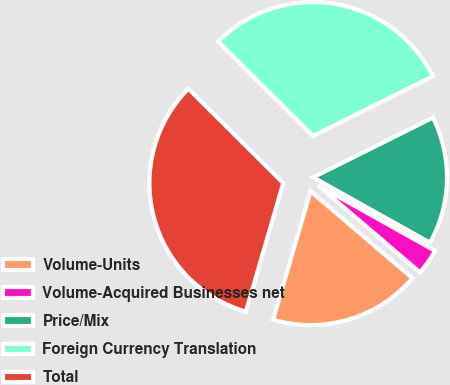<chart> <loc_0><loc_0><loc_500><loc_500><pie_chart><fcel>Volume-Units<fcel>Volume-Acquired Businesses net<fcel>Price/Mix<fcel>Foreign Currency Translation<fcel>Total<nl><fcel>18.26%<fcel>3.13%<fcel>15.48%<fcel>30.18%<fcel>32.96%<nl></chart> 